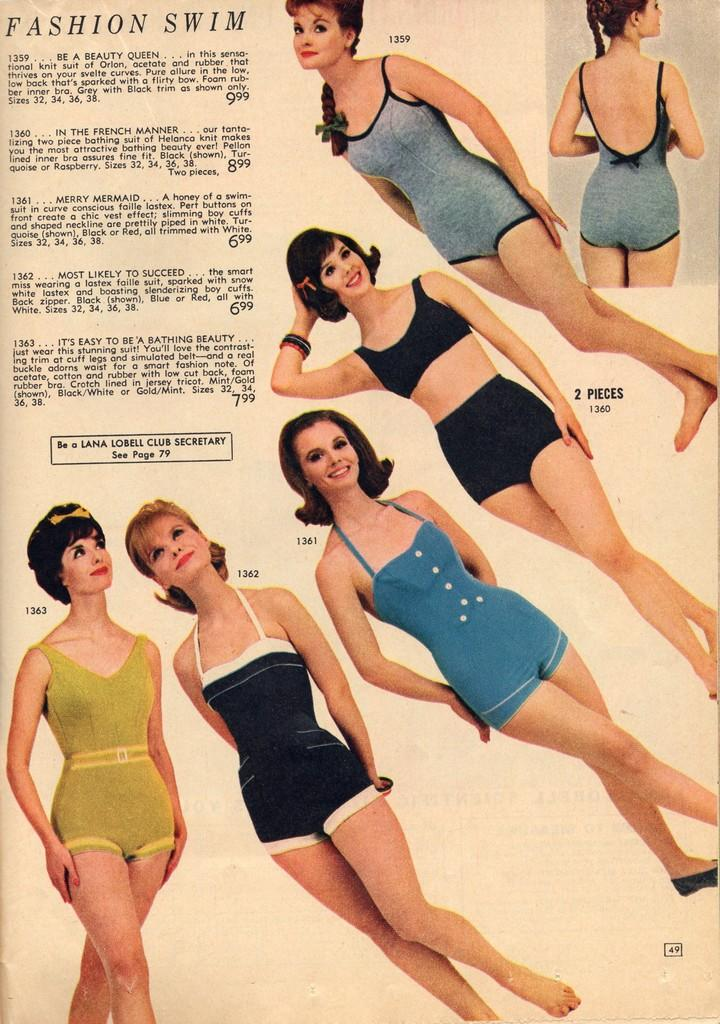What is the main subject of the picture? The main subject of the picture is images of women. How are the women dressed in the image? The women are wearing different color dresses. Where is the text located in the image? The text is in the left top corner of the image. What type of cushion can be seen in the image? There is no cushion present in the image. Can you compare the women's dresses in terms of their patterns and designs? The provided facts do not include information about the patterns or designs of the dresses, so it is not possible to make a comparison. 